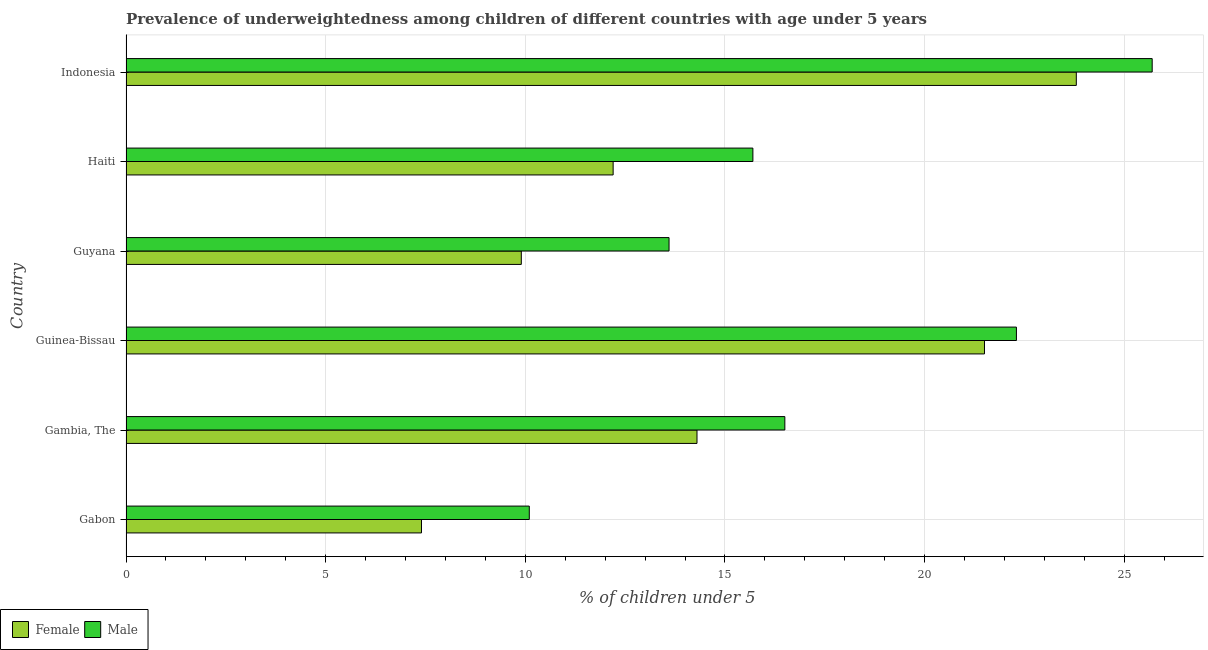Are the number of bars per tick equal to the number of legend labels?
Provide a short and direct response. Yes. Are the number of bars on each tick of the Y-axis equal?
Offer a terse response. Yes. What is the label of the 6th group of bars from the top?
Ensure brevity in your answer.  Gabon. What is the percentage of underweighted female children in Indonesia?
Keep it short and to the point. 23.8. Across all countries, what is the maximum percentage of underweighted male children?
Keep it short and to the point. 25.7. Across all countries, what is the minimum percentage of underweighted female children?
Make the answer very short. 7.4. In which country was the percentage of underweighted male children minimum?
Make the answer very short. Gabon. What is the total percentage of underweighted male children in the graph?
Your response must be concise. 103.9. What is the difference between the percentage of underweighted female children in Gambia, The and the percentage of underweighted male children in Gabon?
Provide a short and direct response. 4.2. What is the average percentage of underweighted male children per country?
Keep it short and to the point. 17.32. What is the ratio of the percentage of underweighted male children in Gabon to that in Guyana?
Provide a succinct answer. 0.74. What is the difference between the highest and the second highest percentage of underweighted male children?
Offer a terse response. 3.4. What is the difference between the highest and the lowest percentage of underweighted male children?
Provide a succinct answer. 15.6. Is the sum of the percentage of underweighted male children in Gabon and Indonesia greater than the maximum percentage of underweighted female children across all countries?
Your answer should be very brief. Yes. What does the 1st bar from the bottom in Indonesia represents?
Ensure brevity in your answer.  Female. How many bars are there?
Provide a succinct answer. 12. How many countries are there in the graph?
Provide a short and direct response. 6. What is the difference between two consecutive major ticks on the X-axis?
Your response must be concise. 5. Are the values on the major ticks of X-axis written in scientific E-notation?
Offer a very short reply. No. Does the graph contain any zero values?
Ensure brevity in your answer.  No. Does the graph contain grids?
Provide a succinct answer. Yes. Where does the legend appear in the graph?
Offer a very short reply. Bottom left. How many legend labels are there?
Offer a very short reply. 2. How are the legend labels stacked?
Provide a succinct answer. Horizontal. What is the title of the graph?
Your answer should be compact. Prevalence of underweightedness among children of different countries with age under 5 years. Does "Female entrants" appear as one of the legend labels in the graph?
Your answer should be very brief. No. What is the label or title of the X-axis?
Give a very brief answer.  % of children under 5. What is the  % of children under 5 in Female in Gabon?
Keep it short and to the point. 7.4. What is the  % of children under 5 of Male in Gabon?
Your response must be concise. 10.1. What is the  % of children under 5 in Female in Gambia, The?
Provide a succinct answer. 14.3. What is the  % of children under 5 of Female in Guinea-Bissau?
Offer a terse response. 21.5. What is the  % of children under 5 in Male in Guinea-Bissau?
Provide a succinct answer. 22.3. What is the  % of children under 5 in Female in Guyana?
Keep it short and to the point. 9.9. What is the  % of children under 5 in Male in Guyana?
Give a very brief answer. 13.6. What is the  % of children under 5 in Female in Haiti?
Your answer should be compact. 12.2. What is the  % of children under 5 in Male in Haiti?
Ensure brevity in your answer.  15.7. What is the  % of children under 5 in Female in Indonesia?
Offer a terse response. 23.8. What is the  % of children under 5 of Male in Indonesia?
Give a very brief answer. 25.7. Across all countries, what is the maximum  % of children under 5 in Female?
Your answer should be very brief. 23.8. Across all countries, what is the maximum  % of children under 5 in Male?
Your answer should be very brief. 25.7. Across all countries, what is the minimum  % of children under 5 in Female?
Offer a very short reply. 7.4. Across all countries, what is the minimum  % of children under 5 in Male?
Offer a terse response. 10.1. What is the total  % of children under 5 in Female in the graph?
Offer a terse response. 89.1. What is the total  % of children under 5 of Male in the graph?
Provide a succinct answer. 103.9. What is the difference between the  % of children under 5 in Female in Gabon and that in Gambia, The?
Your response must be concise. -6.9. What is the difference between the  % of children under 5 in Female in Gabon and that in Guinea-Bissau?
Your answer should be compact. -14.1. What is the difference between the  % of children under 5 of Female in Gabon and that in Indonesia?
Keep it short and to the point. -16.4. What is the difference between the  % of children under 5 in Male in Gabon and that in Indonesia?
Keep it short and to the point. -15.6. What is the difference between the  % of children under 5 in Male in Gambia, The and that in Guyana?
Keep it short and to the point. 2.9. What is the difference between the  % of children under 5 of Female in Gambia, The and that in Haiti?
Give a very brief answer. 2.1. What is the difference between the  % of children under 5 of Male in Gambia, The and that in Haiti?
Give a very brief answer. 0.8. What is the difference between the  % of children under 5 of Female in Gambia, The and that in Indonesia?
Your answer should be very brief. -9.5. What is the difference between the  % of children under 5 in Male in Guinea-Bissau and that in Guyana?
Keep it short and to the point. 8.7. What is the difference between the  % of children under 5 in Male in Guinea-Bissau and that in Haiti?
Ensure brevity in your answer.  6.6. What is the difference between the  % of children under 5 of Male in Guyana and that in Indonesia?
Your answer should be very brief. -12.1. What is the difference between the  % of children under 5 of Female in Haiti and that in Indonesia?
Keep it short and to the point. -11.6. What is the difference between the  % of children under 5 of Female in Gabon and the  % of children under 5 of Male in Gambia, The?
Keep it short and to the point. -9.1. What is the difference between the  % of children under 5 of Female in Gabon and the  % of children under 5 of Male in Guinea-Bissau?
Provide a succinct answer. -14.9. What is the difference between the  % of children under 5 of Female in Gabon and the  % of children under 5 of Male in Guyana?
Provide a short and direct response. -6.2. What is the difference between the  % of children under 5 in Female in Gabon and the  % of children under 5 in Male in Haiti?
Ensure brevity in your answer.  -8.3. What is the difference between the  % of children under 5 of Female in Gabon and the  % of children under 5 of Male in Indonesia?
Provide a succinct answer. -18.3. What is the difference between the  % of children under 5 in Female in Gambia, The and the  % of children under 5 in Male in Guyana?
Make the answer very short. 0.7. What is the difference between the  % of children under 5 of Female in Gambia, The and the  % of children under 5 of Male in Indonesia?
Provide a short and direct response. -11.4. What is the difference between the  % of children under 5 in Female in Guinea-Bissau and the  % of children under 5 in Male in Haiti?
Provide a short and direct response. 5.8. What is the difference between the  % of children under 5 in Female in Guinea-Bissau and the  % of children under 5 in Male in Indonesia?
Provide a succinct answer. -4.2. What is the difference between the  % of children under 5 of Female in Guyana and the  % of children under 5 of Male in Haiti?
Keep it short and to the point. -5.8. What is the difference between the  % of children under 5 of Female in Guyana and the  % of children under 5 of Male in Indonesia?
Your response must be concise. -15.8. What is the difference between the  % of children under 5 in Female in Haiti and the  % of children under 5 in Male in Indonesia?
Provide a short and direct response. -13.5. What is the average  % of children under 5 of Female per country?
Offer a very short reply. 14.85. What is the average  % of children under 5 in Male per country?
Offer a very short reply. 17.32. What is the difference between the  % of children under 5 of Female and  % of children under 5 of Male in Gambia, The?
Provide a succinct answer. -2.2. What is the ratio of the  % of children under 5 in Female in Gabon to that in Gambia, The?
Your answer should be very brief. 0.52. What is the ratio of the  % of children under 5 of Male in Gabon to that in Gambia, The?
Your answer should be compact. 0.61. What is the ratio of the  % of children under 5 in Female in Gabon to that in Guinea-Bissau?
Make the answer very short. 0.34. What is the ratio of the  % of children under 5 in Male in Gabon to that in Guinea-Bissau?
Your answer should be compact. 0.45. What is the ratio of the  % of children under 5 in Female in Gabon to that in Guyana?
Give a very brief answer. 0.75. What is the ratio of the  % of children under 5 in Male in Gabon to that in Guyana?
Provide a short and direct response. 0.74. What is the ratio of the  % of children under 5 of Female in Gabon to that in Haiti?
Offer a very short reply. 0.61. What is the ratio of the  % of children under 5 in Male in Gabon to that in Haiti?
Make the answer very short. 0.64. What is the ratio of the  % of children under 5 of Female in Gabon to that in Indonesia?
Provide a short and direct response. 0.31. What is the ratio of the  % of children under 5 of Male in Gabon to that in Indonesia?
Provide a succinct answer. 0.39. What is the ratio of the  % of children under 5 in Female in Gambia, The to that in Guinea-Bissau?
Ensure brevity in your answer.  0.67. What is the ratio of the  % of children under 5 of Male in Gambia, The to that in Guinea-Bissau?
Offer a very short reply. 0.74. What is the ratio of the  % of children under 5 in Female in Gambia, The to that in Guyana?
Keep it short and to the point. 1.44. What is the ratio of the  % of children under 5 of Male in Gambia, The to that in Guyana?
Your response must be concise. 1.21. What is the ratio of the  % of children under 5 of Female in Gambia, The to that in Haiti?
Your answer should be compact. 1.17. What is the ratio of the  % of children under 5 in Male in Gambia, The to that in Haiti?
Provide a succinct answer. 1.05. What is the ratio of the  % of children under 5 in Female in Gambia, The to that in Indonesia?
Your answer should be compact. 0.6. What is the ratio of the  % of children under 5 in Male in Gambia, The to that in Indonesia?
Your answer should be compact. 0.64. What is the ratio of the  % of children under 5 of Female in Guinea-Bissau to that in Guyana?
Your response must be concise. 2.17. What is the ratio of the  % of children under 5 in Male in Guinea-Bissau to that in Guyana?
Provide a short and direct response. 1.64. What is the ratio of the  % of children under 5 of Female in Guinea-Bissau to that in Haiti?
Provide a short and direct response. 1.76. What is the ratio of the  % of children under 5 in Male in Guinea-Bissau to that in Haiti?
Offer a very short reply. 1.42. What is the ratio of the  % of children under 5 of Female in Guinea-Bissau to that in Indonesia?
Your answer should be compact. 0.9. What is the ratio of the  % of children under 5 in Male in Guinea-Bissau to that in Indonesia?
Your answer should be very brief. 0.87. What is the ratio of the  % of children under 5 of Female in Guyana to that in Haiti?
Keep it short and to the point. 0.81. What is the ratio of the  % of children under 5 in Male in Guyana to that in Haiti?
Keep it short and to the point. 0.87. What is the ratio of the  % of children under 5 of Female in Guyana to that in Indonesia?
Your answer should be very brief. 0.42. What is the ratio of the  % of children under 5 of Male in Guyana to that in Indonesia?
Your answer should be compact. 0.53. What is the ratio of the  % of children under 5 in Female in Haiti to that in Indonesia?
Provide a short and direct response. 0.51. What is the ratio of the  % of children under 5 in Male in Haiti to that in Indonesia?
Make the answer very short. 0.61. What is the difference between the highest and the second highest  % of children under 5 in Female?
Your answer should be very brief. 2.3. What is the difference between the highest and the second highest  % of children under 5 in Male?
Your answer should be very brief. 3.4. What is the difference between the highest and the lowest  % of children under 5 in Male?
Your answer should be compact. 15.6. 